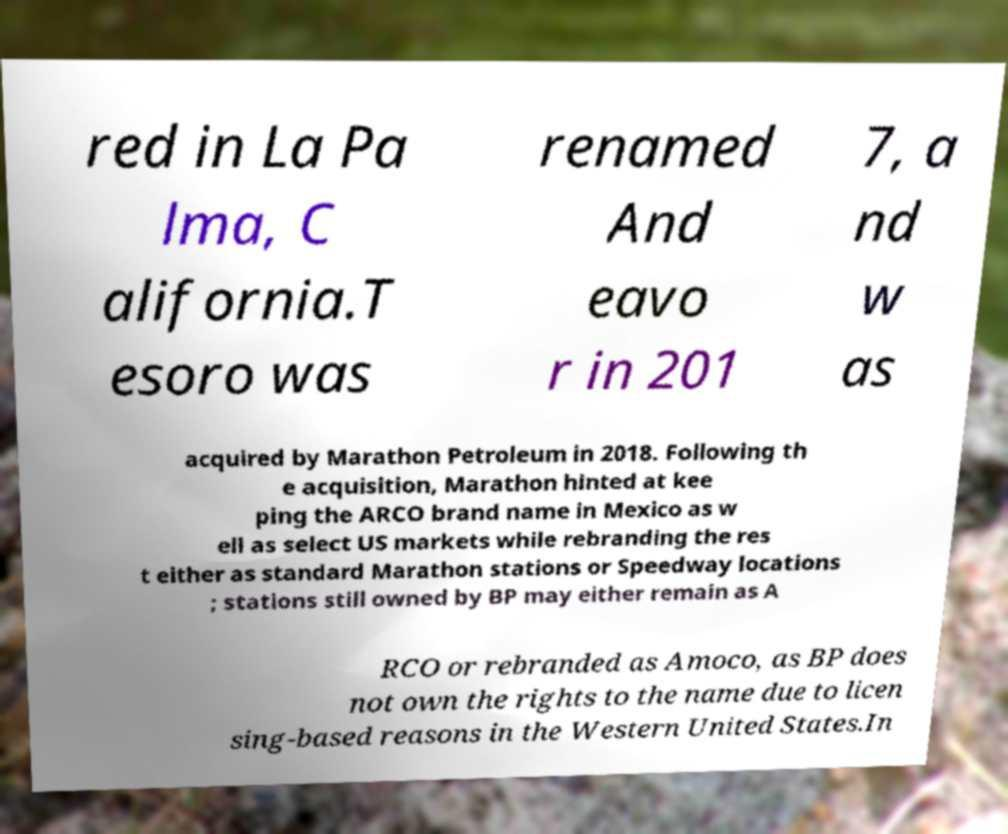Can you read and provide the text displayed in the image?This photo seems to have some interesting text. Can you extract and type it out for me? red in La Pa lma, C alifornia.T esoro was renamed And eavo r in 201 7, a nd w as acquired by Marathon Petroleum in 2018. Following th e acquisition, Marathon hinted at kee ping the ARCO brand name in Mexico as w ell as select US markets while rebranding the res t either as standard Marathon stations or Speedway locations ; stations still owned by BP may either remain as A RCO or rebranded as Amoco, as BP does not own the rights to the name due to licen sing-based reasons in the Western United States.In 